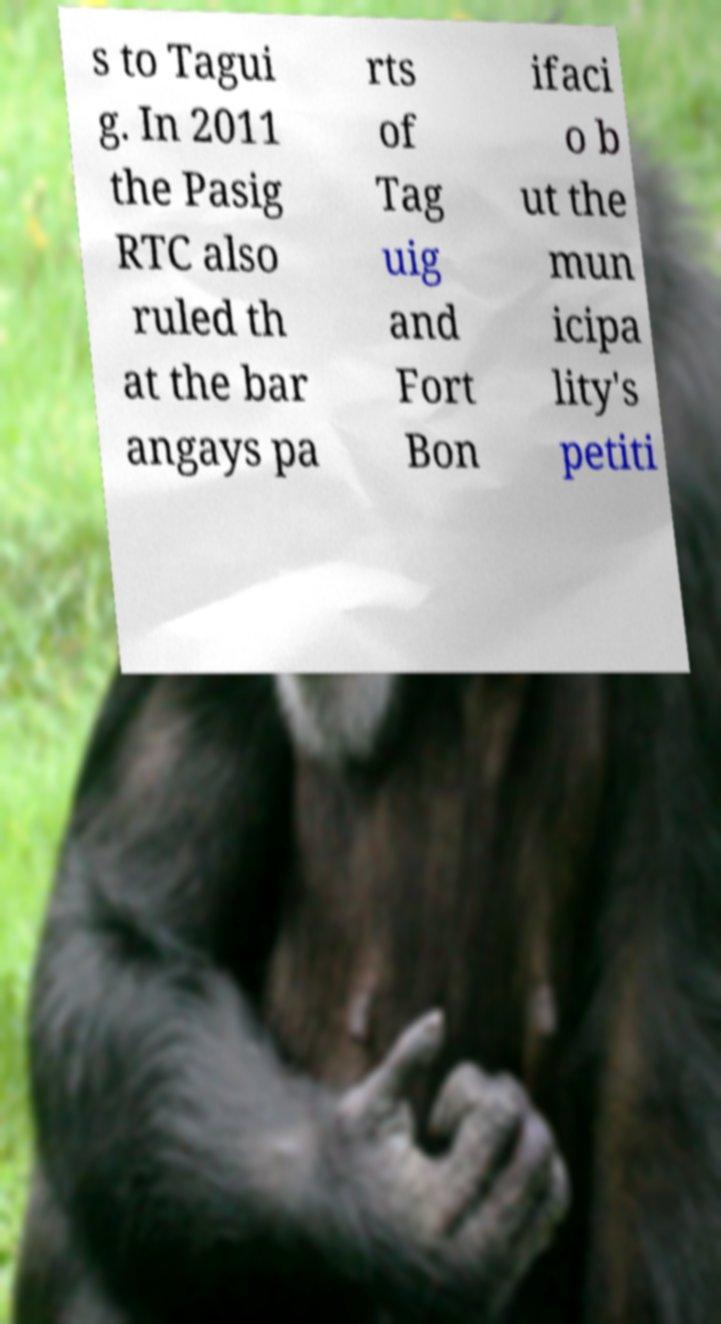Can you read and provide the text displayed in the image?This photo seems to have some interesting text. Can you extract and type it out for me? s to Tagui g. In 2011 the Pasig RTC also ruled th at the bar angays pa rts of Tag uig and Fort Bon ifaci o b ut the mun icipa lity's petiti 